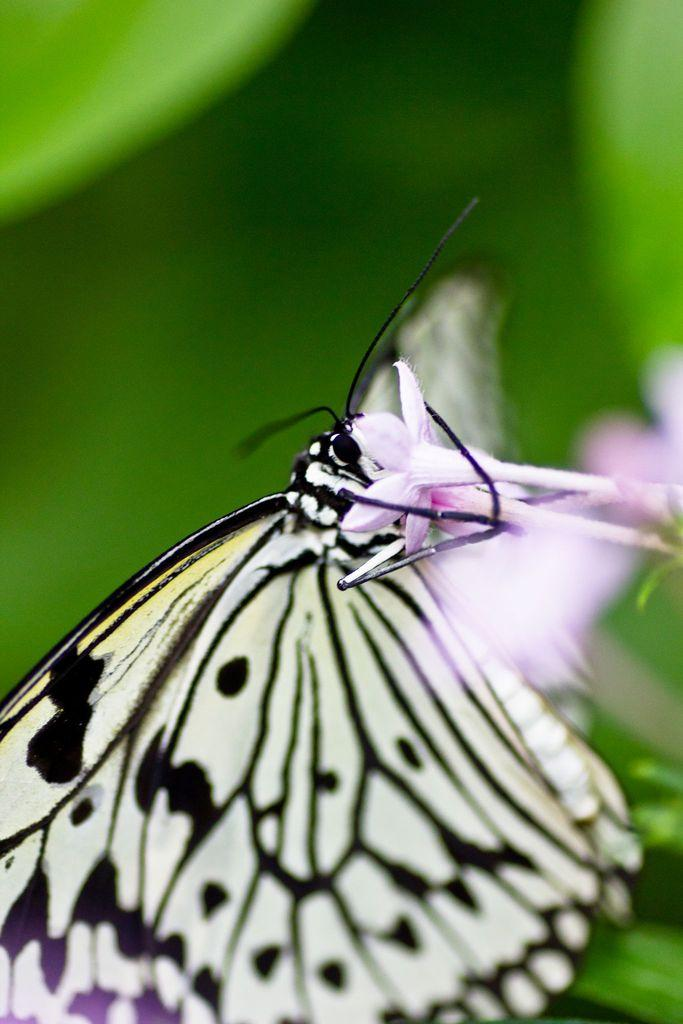What is the main subject of the image? There is a butterfly in the image. What is the butterfly doing in the image? The butterfly is on a pink flower. What colors can be seen on the butterfly? The butterfly has black and yellow colors. How would you describe the background of the image? The background of the image is blurred. Can you hear the voice of the lawyer in the image? There is no voice or lawyer present in the image, as it features a butterfly on a pink flower. 